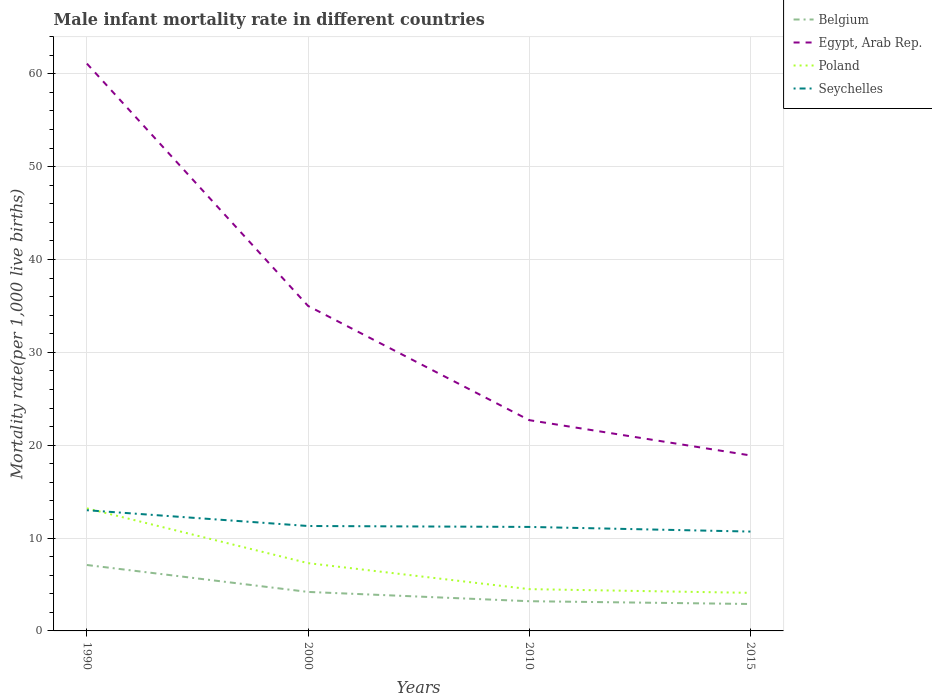How many different coloured lines are there?
Provide a succinct answer. 4. In which year was the male infant mortality rate in Seychelles maximum?
Give a very brief answer. 2015. What is the total male infant mortality rate in Belgium in the graph?
Your answer should be compact. 4.2. What is the difference between the highest and the second highest male infant mortality rate in Egypt, Arab Rep.?
Ensure brevity in your answer.  42.2. What is the difference between the highest and the lowest male infant mortality rate in Poland?
Offer a very short reply. 2. Is the male infant mortality rate in Belgium strictly greater than the male infant mortality rate in Poland over the years?
Give a very brief answer. Yes. How many years are there in the graph?
Offer a terse response. 4. What is the difference between two consecutive major ticks on the Y-axis?
Your response must be concise. 10. Are the values on the major ticks of Y-axis written in scientific E-notation?
Ensure brevity in your answer.  No. Does the graph contain any zero values?
Make the answer very short. No. Does the graph contain grids?
Your answer should be very brief. Yes. Where does the legend appear in the graph?
Your answer should be very brief. Top right. What is the title of the graph?
Ensure brevity in your answer.  Male infant mortality rate in different countries. What is the label or title of the Y-axis?
Provide a succinct answer. Mortality rate(per 1,0 live births). What is the Mortality rate(per 1,000 live births) in Egypt, Arab Rep. in 1990?
Offer a very short reply. 61.1. What is the Mortality rate(per 1,000 live births) of Poland in 2000?
Your answer should be compact. 7.3. What is the Mortality rate(per 1,000 live births) of Egypt, Arab Rep. in 2010?
Provide a succinct answer. 22.7. What is the Mortality rate(per 1,000 live births) of Belgium in 2015?
Offer a very short reply. 2.9. What is the Mortality rate(per 1,000 live births) of Egypt, Arab Rep. in 2015?
Your response must be concise. 18.9. What is the Mortality rate(per 1,000 live births) in Poland in 2015?
Your answer should be compact. 4.1. What is the Mortality rate(per 1,000 live births) of Seychelles in 2015?
Provide a succinct answer. 10.7. Across all years, what is the maximum Mortality rate(per 1,000 live births) of Belgium?
Your response must be concise. 7.1. Across all years, what is the maximum Mortality rate(per 1,000 live births) of Egypt, Arab Rep.?
Provide a short and direct response. 61.1. Across all years, what is the maximum Mortality rate(per 1,000 live births) of Seychelles?
Ensure brevity in your answer.  13. Across all years, what is the minimum Mortality rate(per 1,000 live births) of Belgium?
Offer a terse response. 2.9. Across all years, what is the minimum Mortality rate(per 1,000 live births) of Poland?
Give a very brief answer. 4.1. What is the total Mortality rate(per 1,000 live births) of Egypt, Arab Rep. in the graph?
Give a very brief answer. 137.7. What is the total Mortality rate(per 1,000 live births) in Poland in the graph?
Your answer should be compact. 29.1. What is the total Mortality rate(per 1,000 live births) of Seychelles in the graph?
Offer a terse response. 46.2. What is the difference between the Mortality rate(per 1,000 live births) of Belgium in 1990 and that in 2000?
Keep it short and to the point. 2.9. What is the difference between the Mortality rate(per 1,000 live births) of Egypt, Arab Rep. in 1990 and that in 2000?
Give a very brief answer. 26.1. What is the difference between the Mortality rate(per 1,000 live births) in Seychelles in 1990 and that in 2000?
Make the answer very short. 1.7. What is the difference between the Mortality rate(per 1,000 live births) in Egypt, Arab Rep. in 1990 and that in 2010?
Keep it short and to the point. 38.4. What is the difference between the Mortality rate(per 1,000 live births) of Seychelles in 1990 and that in 2010?
Keep it short and to the point. 1.8. What is the difference between the Mortality rate(per 1,000 live births) in Belgium in 1990 and that in 2015?
Make the answer very short. 4.2. What is the difference between the Mortality rate(per 1,000 live births) in Egypt, Arab Rep. in 1990 and that in 2015?
Your answer should be compact. 42.2. What is the difference between the Mortality rate(per 1,000 live births) of Poland in 1990 and that in 2015?
Make the answer very short. 9.1. What is the difference between the Mortality rate(per 1,000 live births) in Belgium in 2000 and that in 2010?
Your answer should be very brief. 1. What is the difference between the Mortality rate(per 1,000 live births) of Egypt, Arab Rep. in 2000 and that in 2010?
Your response must be concise. 12.3. What is the difference between the Mortality rate(per 1,000 live births) of Poland in 2000 and that in 2010?
Offer a very short reply. 2.8. What is the difference between the Mortality rate(per 1,000 live births) of Seychelles in 2000 and that in 2010?
Keep it short and to the point. 0.1. What is the difference between the Mortality rate(per 1,000 live births) in Egypt, Arab Rep. in 2000 and that in 2015?
Ensure brevity in your answer.  16.1. What is the difference between the Mortality rate(per 1,000 live births) of Poland in 2000 and that in 2015?
Your answer should be compact. 3.2. What is the difference between the Mortality rate(per 1,000 live births) in Belgium in 2010 and that in 2015?
Keep it short and to the point. 0.3. What is the difference between the Mortality rate(per 1,000 live births) in Egypt, Arab Rep. in 2010 and that in 2015?
Give a very brief answer. 3.8. What is the difference between the Mortality rate(per 1,000 live births) of Seychelles in 2010 and that in 2015?
Keep it short and to the point. 0.5. What is the difference between the Mortality rate(per 1,000 live births) in Belgium in 1990 and the Mortality rate(per 1,000 live births) in Egypt, Arab Rep. in 2000?
Keep it short and to the point. -27.9. What is the difference between the Mortality rate(per 1,000 live births) in Egypt, Arab Rep. in 1990 and the Mortality rate(per 1,000 live births) in Poland in 2000?
Provide a short and direct response. 53.8. What is the difference between the Mortality rate(per 1,000 live births) of Egypt, Arab Rep. in 1990 and the Mortality rate(per 1,000 live births) of Seychelles in 2000?
Provide a succinct answer. 49.8. What is the difference between the Mortality rate(per 1,000 live births) in Belgium in 1990 and the Mortality rate(per 1,000 live births) in Egypt, Arab Rep. in 2010?
Provide a short and direct response. -15.6. What is the difference between the Mortality rate(per 1,000 live births) in Belgium in 1990 and the Mortality rate(per 1,000 live births) in Seychelles in 2010?
Offer a terse response. -4.1. What is the difference between the Mortality rate(per 1,000 live births) of Egypt, Arab Rep. in 1990 and the Mortality rate(per 1,000 live births) of Poland in 2010?
Make the answer very short. 56.6. What is the difference between the Mortality rate(per 1,000 live births) in Egypt, Arab Rep. in 1990 and the Mortality rate(per 1,000 live births) in Seychelles in 2010?
Offer a very short reply. 49.9. What is the difference between the Mortality rate(per 1,000 live births) in Poland in 1990 and the Mortality rate(per 1,000 live births) in Seychelles in 2010?
Offer a very short reply. 2. What is the difference between the Mortality rate(per 1,000 live births) of Egypt, Arab Rep. in 1990 and the Mortality rate(per 1,000 live births) of Seychelles in 2015?
Keep it short and to the point. 50.4. What is the difference between the Mortality rate(per 1,000 live births) in Poland in 1990 and the Mortality rate(per 1,000 live births) in Seychelles in 2015?
Ensure brevity in your answer.  2.5. What is the difference between the Mortality rate(per 1,000 live births) of Belgium in 2000 and the Mortality rate(per 1,000 live births) of Egypt, Arab Rep. in 2010?
Your answer should be compact. -18.5. What is the difference between the Mortality rate(per 1,000 live births) of Belgium in 2000 and the Mortality rate(per 1,000 live births) of Poland in 2010?
Offer a very short reply. -0.3. What is the difference between the Mortality rate(per 1,000 live births) in Egypt, Arab Rep. in 2000 and the Mortality rate(per 1,000 live births) in Poland in 2010?
Your response must be concise. 30.5. What is the difference between the Mortality rate(per 1,000 live births) in Egypt, Arab Rep. in 2000 and the Mortality rate(per 1,000 live births) in Seychelles in 2010?
Give a very brief answer. 23.8. What is the difference between the Mortality rate(per 1,000 live births) of Poland in 2000 and the Mortality rate(per 1,000 live births) of Seychelles in 2010?
Your answer should be very brief. -3.9. What is the difference between the Mortality rate(per 1,000 live births) of Belgium in 2000 and the Mortality rate(per 1,000 live births) of Egypt, Arab Rep. in 2015?
Give a very brief answer. -14.7. What is the difference between the Mortality rate(per 1,000 live births) in Egypt, Arab Rep. in 2000 and the Mortality rate(per 1,000 live births) in Poland in 2015?
Your answer should be compact. 30.9. What is the difference between the Mortality rate(per 1,000 live births) of Egypt, Arab Rep. in 2000 and the Mortality rate(per 1,000 live births) of Seychelles in 2015?
Offer a very short reply. 24.3. What is the difference between the Mortality rate(per 1,000 live births) in Belgium in 2010 and the Mortality rate(per 1,000 live births) in Egypt, Arab Rep. in 2015?
Offer a terse response. -15.7. What is the difference between the Mortality rate(per 1,000 live births) of Belgium in 2010 and the Mortality rate(per 1,000 live births) of Poland in 2015?
Your answer should be very brief. -0.9. What is the difference between the Mortality rate(per 1,000 live births) of Belgium in 2010 and the Mortality rate(per 1,000 live births) of Seychelles in 2015?
Offer a very short reply. -7.5. What is the difference between the Mortality rate(per 1,000 live births) of Egypt, Arab Rep. in 2010 and the Mortality rate(per 1,000 live births) of Poland in 2015?
Make the answer very short. 18.6. What is the difference between the Mortality rate(per 1,000 live births) in Poland in 2010 and the Mortality rate(per 1,000 live births) in Seychelles in 2015?
Provide a succinct answer. -6.2. What is the average Mortality rate(per 1,000 live births) in Belgium per year?
Offer a very short reply. 4.35. What is the average Mortality rate(per 1,000 live births) in Egypt, Arab Rep. per year?
Your answer should be compact. 34.42. What is the average Mortality rate(per 1,000 live births) of Poland per year?
Provide a succinct answer. 7.28. What is the average Mortality rate(per 1,000 live births) of Seychelles per year?
Give a very brief answer. 11.55. In the year 1990, what is the difference between the Mortality rate(per 1,000 live births) in Belgium and Mortality rate(per 1,000 live births) in Egypt, Arab Rep.?
Ensure brevity in your answer.  -54. In the year 1990, what is the difference between the Mortality rate(per 1,000 live births) in Belgium and Mortality rate(per 1,000 live births) in Poland?
Make the answer very short. -6.1. In the year 1990, what is the difference between the Mortality rate(per 1,000 live births) of Belgium and Mortality rate(per 1,000 live births) of Seychelles?
Provide a succinct answer. -5.9. In the year 1990, what is the difference between the Mortality rate(per 1,000 live births) in Egypt, Arab Rep. and Mortality rate(per 1,000 live births) in Poland?
Keep it short and to the point. 47.9. In the year 1990, what is the difference between the Mortality rate(per 1,000 live births) of Egypt, Arab Rep. and Mortality rate(per 1,000 live births) of Seychelles?
Offer a very short reply. 48.1. In the year 2000, what is the difference between the Mortality rate(per 1,000 live births) in Belgium and Mortality rate(per 1,000 live births) in Egypt, Arab Rep.?
Provide a short and direct response. -30.8. In the year 2000, what is the difference between the Mortality rate(per 1,000 live births) in Belgium and Mortality rate(per 1,000 live births) in Seychelles?
Provide a short and direct response. -7.1. In the year 2000, what is the difference between the Mortality rate(per 1,000 live births) in Egypt, Arab Rep. and Mortality rate(per 1,000 live births) in Poland?
Your answer should be compact. 27.7. In the year 2000, what is the difference between the Mortality rate(per 1,000 live births) of Egypt, Arab Rep. and Mortality rate(per 1,000 live births) of Seychelles?
Provide a short and direct response. 23.7. In the year 2010, what is the difference between the Mortality rate(per 1,000 live births) in Belgium and Mortality rate(per 1,000 live births) in Egypt, Arab Rep.?
Provide a succinct answer. -19.5. In the year 2010, what is the difference between the Mortality rate(per 1,000 live births) of Belgium and Mortality rate(per 1,000 live births) of Seychelles?
Offer a terse response. -8. In the year 2015, what is the difference between the Mortality rate(per 1,000 live births) in Belgium and Mortality rate(per 1,000 live births) in Egypt, Arab Rep.?
Your answer should be very brief. -16. In the year 2015, what is the difference between the Mortality rate(per 1,000 live births) in Belgium and Mortality rate(per 1,000 live births) in Poland?
Provide a succinct answer. -1.2. In the year 2015, what is the difference between the Mortality rate(per 1,000 live births) in Belgium and Mortality rate(per 1,000 live births) in Seychelles?
Ensure brevity in your answer.  -7.8. What is the ratio of the Mortality rate(per 1,000 live births) of Belgium in 1990 to that in 2000?
Make the answer very short. 1.69. What is the ratio of the Mortality rate(per 1,000 live births) in Egypt, Arab Rep. in 1990 to that in 2000?
Make the answer very short. 1.75. What is the ratio of the Mortality rate(per 1,000 live births) in Poland in 1990 to that in 2000?
Provide a succinct answer. 1.81. What is the ratio of the Mortality rate(per 1,000 live births) of Seychelles in 1990 to that in 2000?
Your answer should be very brief. 1.15. What is the ratio of the Mortality rate(per 1,000 live births) of Belgium in 1990 to that in 2010?
Offer a terse response. 2.22. What is the ratio of the Mortality rate(per 1,000 live births) of Egypt, Arab Rep. in 1990 to that in 2010?
Your answer should be compact. 2.69. What is the ratio of the Mortality rate(per 1,000 live births) of Poland in 1990 to that in 2010?
Keep it short and to the point. 2.93. What is the ratio of the Mortality rate(per 1,000 live births) in Seychelles in 1990 to that in 2010?
Your answer should be very brief. 1.16. What is the ratio of the Mortality rate(per 1,000 live births) of Belgium in 1990 to that in 2015?
Your answer should be compact. 2.45. What is the ratio of the Mortality rate(per 1,000 live births) of Egypt, Arab Rep. in 1990 to that in 2015?
Provide a short and direct response. 3.23. What is the ratio of the Mortality rate(per 1,000 live births) of Poland in 1990 to that in 2015?
Your answer should be very brief. 3.22. What is the ratio of the Mortality rate(per 1,000 live births) in Seychelles in 1990 to that in 2015?
Offer a terse response. 1.22. What is the ratio of the Mortality rate(per 1,000 live births) in Belgium in 2000 to that in 2010?
Offer a terse response. 1.31. What is the ratio of the Mortality rate(per 1,000 live births) of Egypt, Arab Rep. in 2000 to that in 2010?
Provide a short and direct response. 1.54. What is the ratio of the Mortality rate(per 1,000 live births) of Poland in 2000 to that in 2010?
Make the answer very short. 1.62. What is the ratio of the Mortality rate(per 1,000 live births) of Seychelles in 2000 to that in 2010?
Keep it short and to the point. 1.01. What is the ratio of the Mortality rate(per 1,000 live births) in Belgium in 2000 to that in 2015?
Keep it short and to the point. 1.45. What is the ratio of the Mortality rate(per 1,000 live births) of Egypt, Arab Rep. in 2000 to that in 2015?
Ensure brevity in your answer.  1.85. What is the ratio of the Mortality rate(per 1,000 live births) of Poland in 2000 to that in 2015?
Offer a very short reply. 1.78. What is the ratio of the Mortality rate(per 1,000 live births) in Seychelles in 2000 to that in 2015?
Your answer should be compact. 1.06. What is the ratio of the Mortality rate(per 1,000 live births) in Belgium in 2010 to that in 2015?
Your answer should be compact. 1.1. What is the ratio of the Mortality rate(per 1,000 live births) in Egypt, Arab Rep. in 2010 to that in 2015?
Provide a succinct answer. 1.2. What is the ratio of the Mortality rate(per 1,000 live births) of Poland in 2010 to that in 2015?
Provide a short and direct response. 1.1. What is the ratio of the Mortality rate(per 1,000 live births) of Seychelles in 2010 to that in 2015?
Provide a short and direct response. 1.05. What is the difference between the highest and the second highest Mortality rate(per 1,000 live births) of Egypt, Arab Rep.?
Ensure brevity in your answer.  26.1. What is the difference between the highest and the second highest Mortality rate(per 1,000 live births) in Seychelles?
Ensure brevity in your answer.  1.7. What is the difference between the highest and the lowest Mortality rate(per 1,000 live births) of Egypt, Arab Rep.?
Your answer should be compact. 42.2. What is the difference between the highest and the lowest Mortality rate(per 1,000 live births) in Poland?
Your answer should be very brief. 9.1. What is the difference between the highest and the lowest Mortality rate(per 1,000 live births) of Seychelles?
Offer a very short reply. 2.3. 